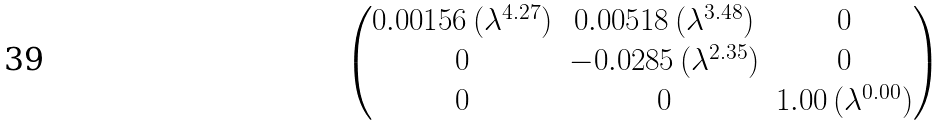<formula> <loc_0><loc_0><loc_500><loc_500>\begin{pmatrix} 0 . 0 0 1 5 6 \, ( \lambda ^ { 4 . 2 7 } ) & 0 . 0 0 5 1 8 \, ( \lambda ^ { 3 . 4 8 } ) & 0 \\ 0 & - 0 . 0 2 8 5 \, ( \lambda ^ { 2 . 3 5 } ) & 0 \\ 0 & 0 & 1 . 0 0 \, ( \lambda ^ { 0 . 0 0 } ) \end{pmatrix}</formula> 